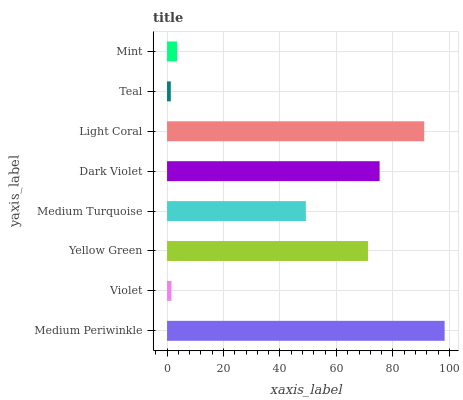Is Teal the minimum?
Answer yes or no. Yes. Is Medium Periwinkle the maximum?
Answer yes or no. Yes. Is Violet the minimum?
Answer yes or no. No. Is Violet the maximum?
Answer yes or no. No. Is Medium Periwinkle greater than Violet?
Answer yes or no. Yes. Is Violet less than Medium Periwinkle?
Answer yes or no. Yes. Is Violet greater than Medium Periwinkle?
Answer yes or no. No. Is Medium Periwinkle less than Violet?
Answer yes or no. No. Is Yellow Green the high median?
Answer yes or no. Yes. Is Medium Turquoise the low median?
Answer yes or no. Yes. Is Medium Turquoise the high median?
Answer yes or no. No. Is Medium Periwinkle the low median?
Answer yes or no. No. 